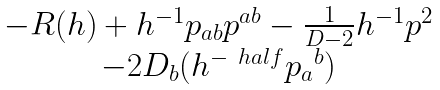Convert formula to latex. <formula><loc_0><loc_0><loc_500><loc_500>\begin{matrix} - R ( h ) + h ^ { - 1 } p _ { a b } p ^ { a b } - \frac { 1 } { D - 2 } h ^ { - 1 } p ^ { 2 } \\ - 2 D _ { b } ( h ^ { - \ h a l f } { p _ { a } } ^ { b } ) \end{matrix}</formula> 